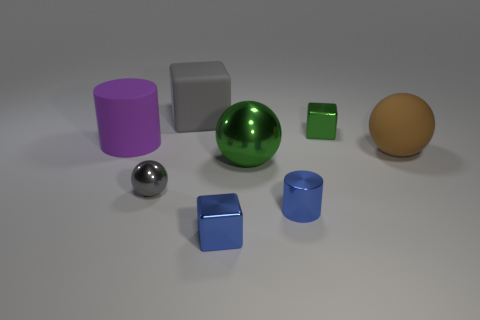What is the possible size relation between the objects? The objects seem to vary in size, which can be inferred based on their relative proportions to one another. The gray ball appears to be mid-sized, while the purple cylinder and orange sphere are the largest. The metallic sphere and the two cubes are smaller in comparison, with the blue cube, in particular, appearing to be the tiniest. 